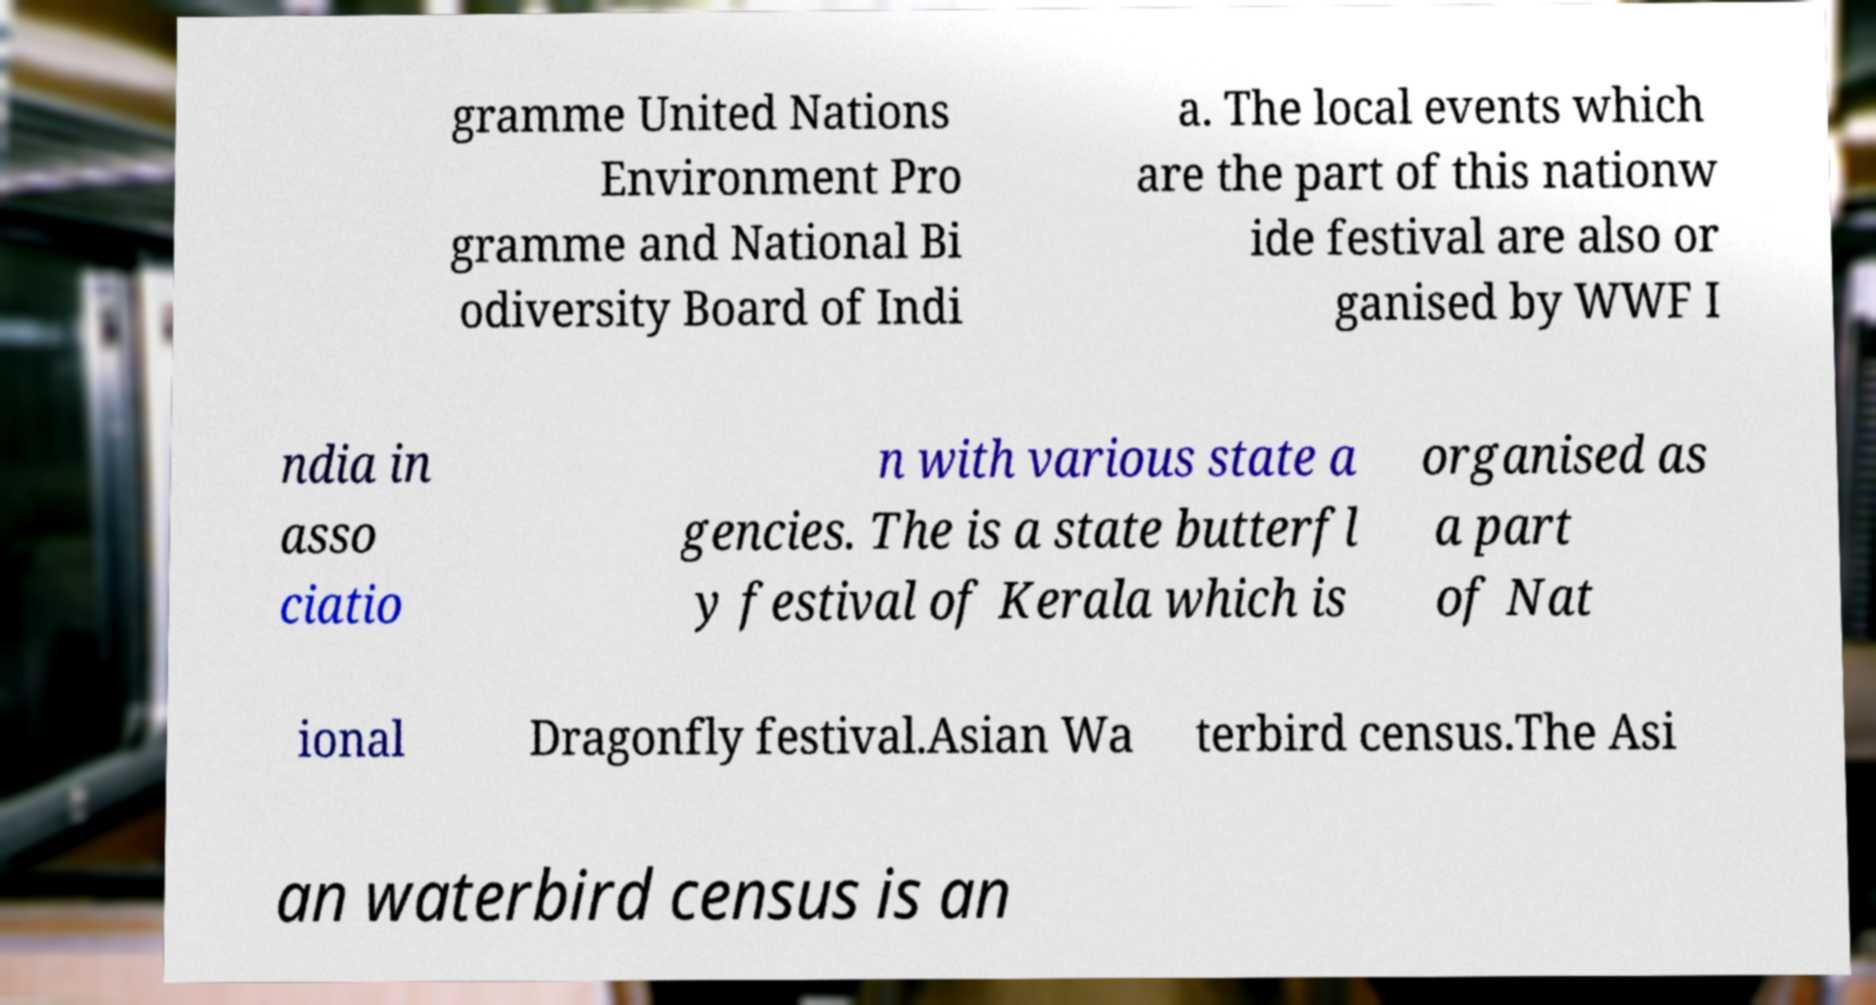Could you assist in decoding the text presented in this image and type it out clearly? gramme United Nations Environment Pro gramme and National Bi odiversity Board of Indi a. The local events which are the part of this nationw ide festival are also or ganised by WWF I ndia in asso ciatio n with various state a gencies. The is a state butterfl y festival of Kerala which is organised as a part of Nat ional Dragonfly festival.Asian Wa terbird census.The Asi an waterbird census is an 